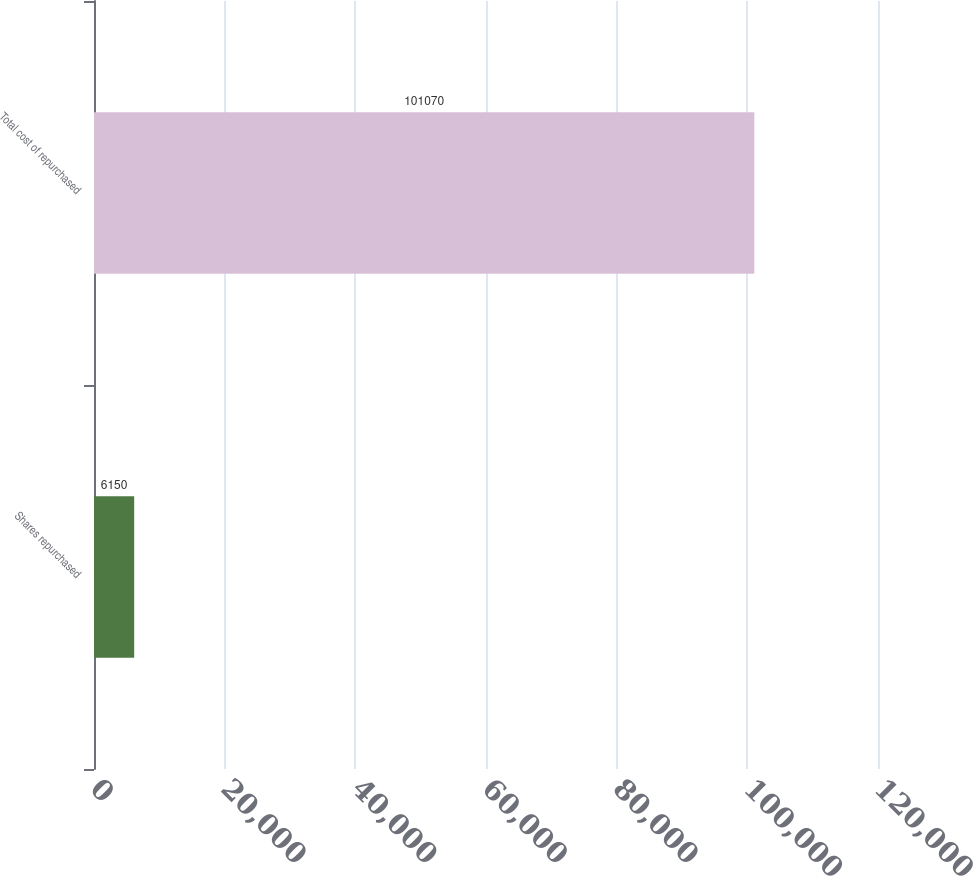<chart> <loc_0><loc_0><loc_500><loc_500><bar_chart><fcel>Shares repurchased<fcel>Total cost of repurchased<nl><fcel>6150<fcel>101070<nl></chart> 